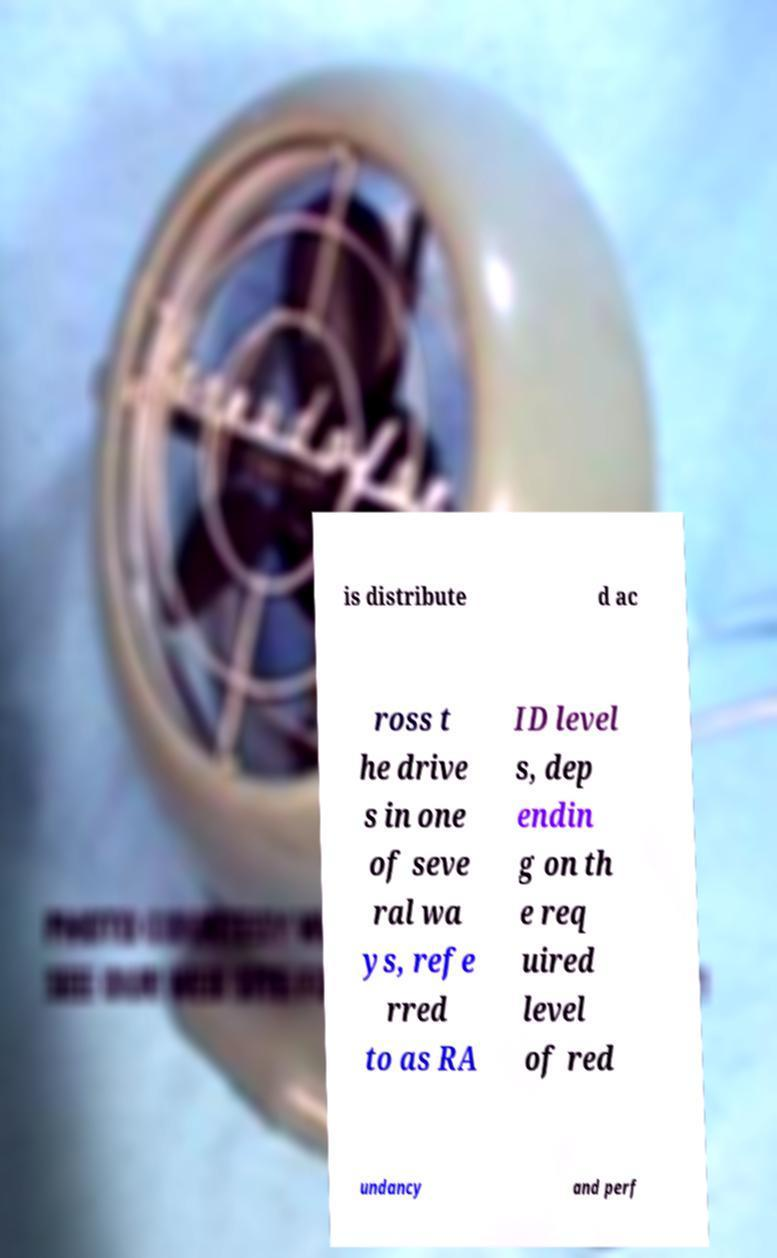I need the written content from this picture converted into text. Can you do that? is distribute d ac ross t he drive s in one of seve ral wa ys, refe rred to as RA ID level s, dep endin g on th e req uired level of red undancy and perf 